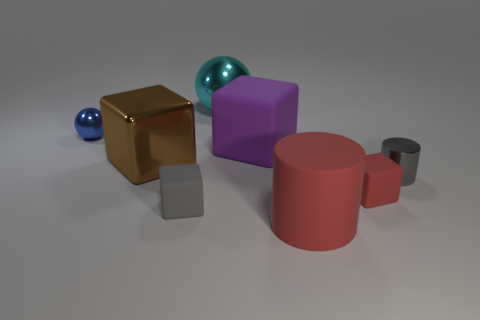Are there fewer gray things that are in front of the small gray matte cube than things in front of the small red matte object?
Offer a very short reply. Yes. How many other objects are the same size as the cyan shiny ball?
Make the answer very short. 3. The tiny rubber thing right of the rubber thing that is behind the large metallic object that is in front of the large cyan metal object is what shape?
Ensure brevity in your answer.  Cube. How many red things are either shiny things or large cylinders?
Provide a succinct answer. 1. What number of large objects are right of the tiny rubber cube behind the gray matte object?
Keep it short and to the point. 0. Is there anything else of the same color as the rubber cylinder?
Your answer should be very brief. Yes. What is the shape of the small thing that is the same material as the tiny red block?
Your answer should be compact. Cube. Is the big shiny cube the same color as the small metallic cylinder?
Make the answer very short. No. Are the tiny gray thing that is on the left side of the small gray metallic cylinder and the cylinder that is behind the large red matte cylinder made of the same material?
Keep it short and to the point. No. What number of objects are gray rubber cubes or small metal things that are in front of the shiny cube?
Offer a terse response. 2. 